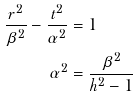Convert formula to latex. <formula><loc_0><loc_0><loc_500><loc_500>\frac { r ^ { 2 } } { \beta ^ { 2 } } - \frac { t ^ { 2 } } { \alpha ^ { 2 } } & = 1 \\ \alpha ^ { 2 } & = \frac { \beta ^ { 2 } } { h ^ { 2 } - 1 }</formula> 